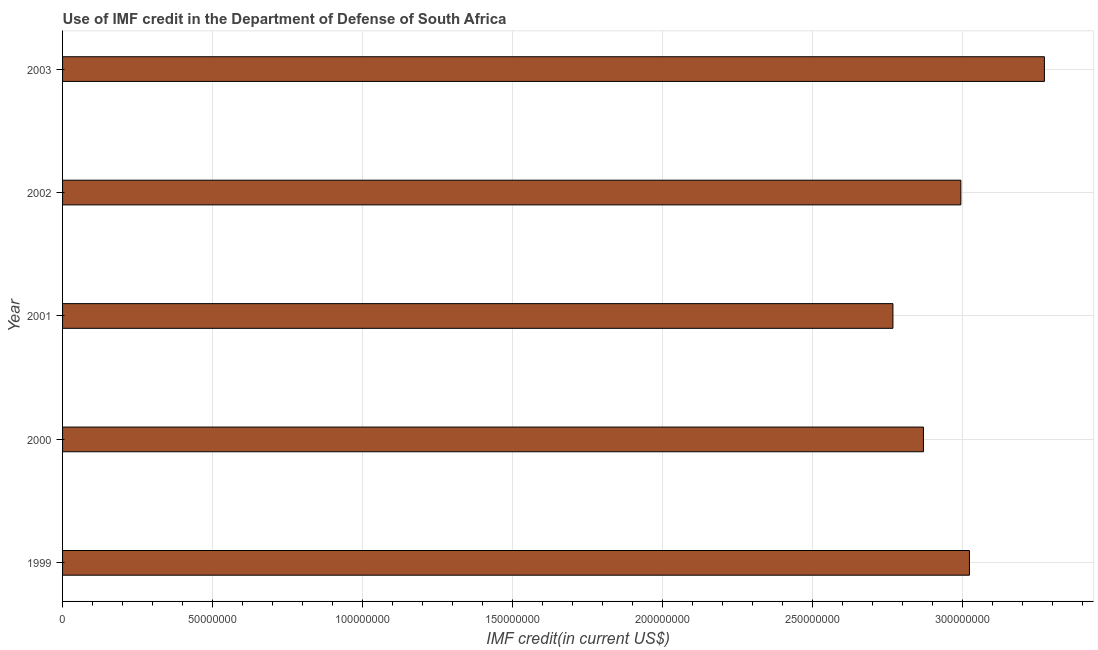Does the graph contain grids?
Your answer should be compact. Yes. What is the title of the graph?
Your answer should be very brief. Use of IMF credit in the Department of Defense of South Africa. What is the label or title of the X-axis?
Provide a succinct answer. IMF credit(in current US$). What is the label or title of the Y-axis?
Make the answer very short. Year. What is the use of imf credit in dod in 2000?
Your answer should be very brief. 2.87e+08. Across all years, what is the maximum use of imf credit in dod?
Ensure brevity in your answer.  3.27e+08. Across all years, what is the minimum use of imf credit in dod?
Keep it short and to the point. 2.77e+08. In which year was the use of imf credit in dod maximum?
Offer a terse response. 2003. What is the sum of the use of imf credit in dod?
Keep it short and to the point. 1.49e+09. What is the difference between the use of imf credit in dod in 1999 and 2001?
Offer a very short reply. 2.55e+07. What is the average use of imf credit in dod per year?
Give a very brief answer. 2.99e+08. What is the median use of imf credit in dod?
Provide a short and direct response. 3.00e+08. In how many years, is the use of imf credit in dod greater than 70000000 US$?
Keep it short and to the point. 5. What is the ratio of the use of imf credit in dod in 2001 to that in 2003?
Give a very brief answer. 0.85. Is the use of imf credit in dod in 2001 less than that in 2002?
Offer a very short reply. Yes. Is the difference between the use of imf credit in dod in 1999 and 2000 greater than the difference between any two years?
Your answer should be compact. No. What is the difference between the highest and the second highest use of imf credit in dod?
Your response must be concise. 2.50e+07. Is the sum of the use of imf credit in dod in 1999 and 2002 greater than the maximum use of imf credit in dod across all years?
Give a very brief answer. Yes. What is the difference between the highest and the lowest use of imf credit in dod?
Make the answer very short. 5.05e+07. How many bars are there?
Your response must be concise. 5. Are all the bars in the graph horizontal?
Make the answer very short. Yes. What is the difference between two consecutive major ticks on the X-axis?
Your response must be concise. 5.00e+07. What is the IMF credit(in current US$) in 1999?
Your response must be concise. 3.02e+08. What is the IMF credit(in current US$) of 2000?
Your response must be concise. 2.87e+08. What is the IMF credit(in current US$) of 2001?
Ensure brevity in your answer.  2.77e+08. What is the IMF credit(in current US$) in 2002?
Make the answer very short. 3.00e+08. What is the IMF credit(in current US$) in 2003?
Offer a terse response. 3.27e+08. What is the difference between the IMF credit(in current US$) in 1999 and 2000?
Keep it short and to the point. 1.53e+07. What is the difference between the IMF credit(in current US$) in 1999 and 2001?
Your answer should be compact. 2.55e+07. What is the difference between the IMF credit(in current US$) in 1999 and 2002?
Give a very brief answer. 2.86e+06. What is the difference between the IMF credit(in current US$) in 1999 and 2003?
Provide a short and direct response. -2.50e+07. What is the difference between the IMF credit(in current US$) in 2000 and 2001?
Offer a very short reply. 1.02e+07. What is the difference between the IMF credit(in current US$) in 2000 and 2002?
Your response must be concise. -1.25e+07. What is the difference between the IMF credit(in current US$) in 2000 and 2003?
Keep it short and to the point. -4.03e+07. What is the difference between the IMF credit(in current US$) in 2001 and 2002?
Your response must be concise. -2.27e+07. What is the difference between the IMF credit(in current US$) in 2001 and 2003?
Offer a very short reply. -5.05e+07. What is the difference between the IMF credit(in current US$) in 2002 and 2003?
Provide a short and direct response. -2.79e+07. What is the ratio of the IMF credit(in current US$) in 1999 to that in 2000?
Offer a very short reply. 1.05. What is the ratio of the IMF credit(in current US$) in 1999 to that in 2001?
Provide a succinct answer. 1.09. What is the ratio of the IMF credit(in current US$) in 1999 to that in 2003?
Your answer should be compact. 0.92. What is the ratio of the IMF credit(in current US$) in 2000 to that in 2001?
Provide a short and direct response. 1.04. What is the ratio of the IMF credit(in current US$) in 2000 to that in 2002?
Offer a terse response. 0.96. What is the ratio of the IMF credit(in current US$) in 2000 to that in 2003?
Ensure brevity in your answer.  0.88. What is the ratio of the IMF credit(in current US$) in 2001 to that in 2002?
Keep it short and to the point. 0.92. What is the ratio of the IMF credit(in current US$) in 2001 to that in 2003?
Ensure brevity in your answer.  0.85. What is the ratio of the IMF credit(in current US$) in 2002 to that in 2003?
Give a very brief answer. 0.92. 